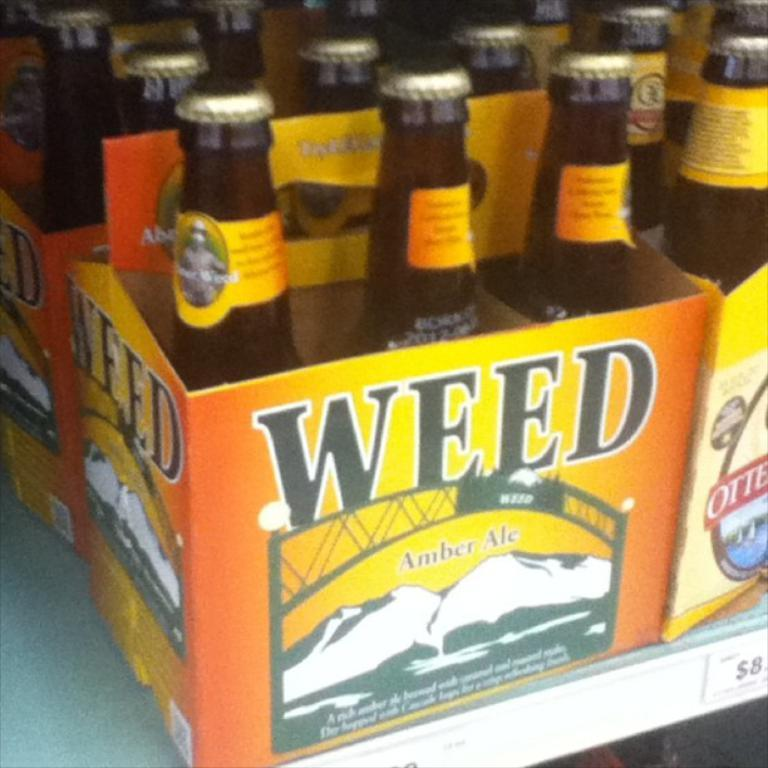Provide a one-sentence caption for the provided image. A six pack of Weed amber ale beer in brown glass bottles. 